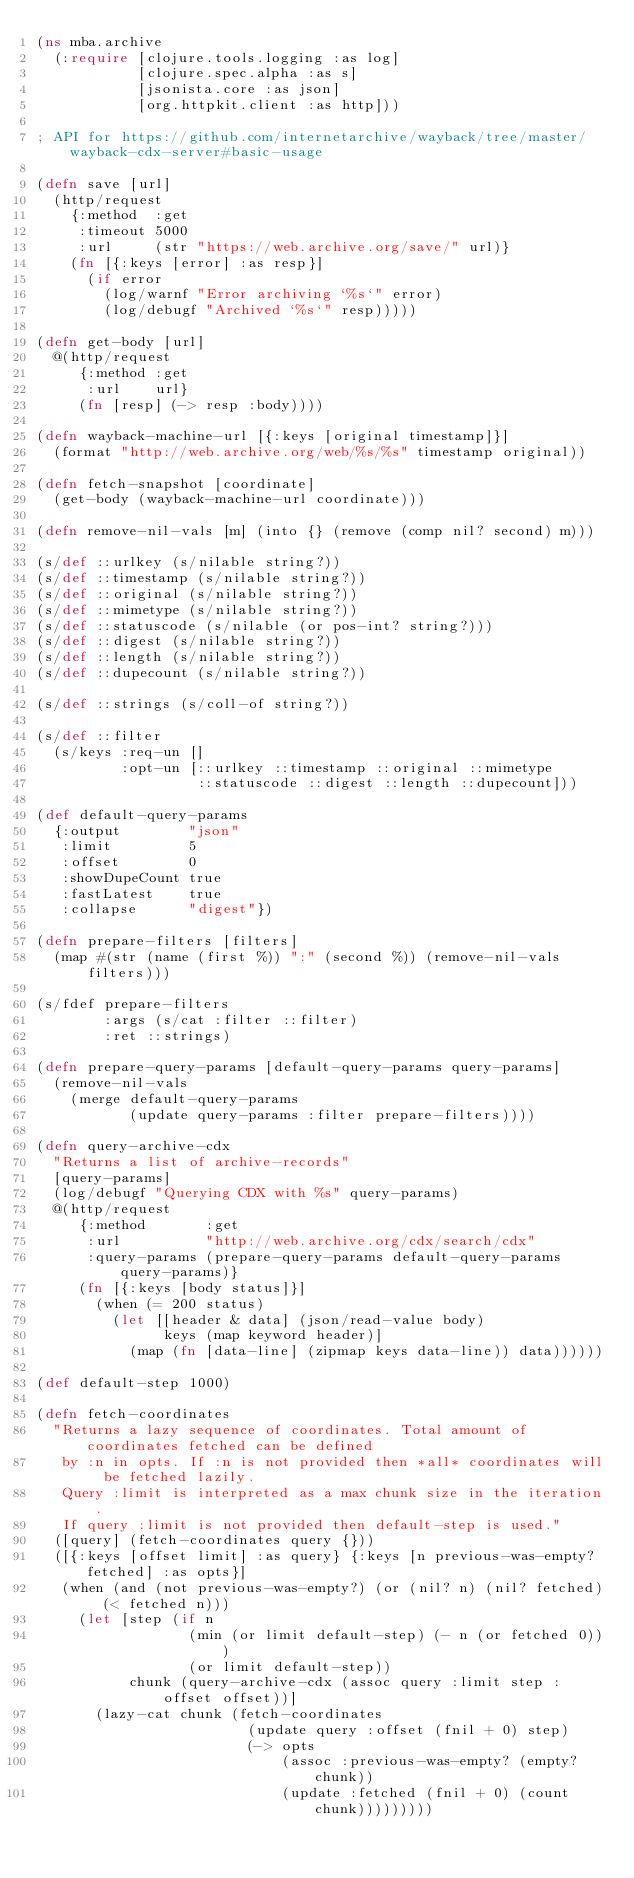Convert code to text. <code><loc_0><loc_0><loc_500><loc_500><_Clojure_>(ns mba.archive
  (:require [clojure.tools.logging :as log]
            [clojure.spec.alpha :as s]
            [jsonista.core :as json]
            [org.httpkit.client :as http]))

; API for https://github.com/internetarchive/wayback/tree/master/wayback-cdx-server#basic-usage

(defn save [url]
  (http/request
    {:method  :get
     :timeout 5000
     :url     (str "https://web.archive.org/save/" url)}
    (fn [{:keys [error] :as resp}]
      (if error
        (log/warnf "Error archiving `%s`" error)
        (log/debugf "Archived `%s`" resp)))))

(defn get-body [url]
  @(http/request
     {:method :get
      :url    url}
     (fn [resp] (-> resp :body))))

(defn wayback-machine-url [{:keys [original timestamp]}]
  (format "http://web.archive.org/web/%s/%s" timestamp original))

(defn fetch-snapshot [coordinate]
  (get-body (wayback-machine-url coordinate)))

(defn remove-nil-vals [m] (into {} (remove (comp nil? second) m)))

(s/def ::urlkey (s/nilable string?))
(s/def ::timestamp (s/nilable string?))
(s/def ::original (s/nilable string?))
(s/def ::mimetype (s/nilable string?))
(s/def ::statuscode (s/nilable (or pos-int? string?)))
(s/def ::digest (s/nilable string?))
(s/def ::length (s/nilable string?))
(s/def ::dupecount (s/nilable string?))

(s/def ::strings (s/coll-of string?))

(s/def ::filter
  (s/keys :req-un []
          :opt-un [::urlkey ::timestamp ::original ::mimetype
                   ::statuscode ::digest ::length ::dupecount]))

(def default-query-params
  {:output        "json"
   :limit         5
   :offset        0
   :showDupeCount true
   :fastLatest    true
   :collapse      "digest"})

(defn prepare-filters [filters]
  (map #(str (name (first %)) ":" (second %)) (remove-nil-vals filters)))

(s/fdef prepare-filters
        :args (s/cat :filter ::filter)
        :ret ::strings)

(defn prepare-query-params [default-query-params query-params]
  (remove-nil-vals
    (merge default-query-params
           (update query-params :filter prepare-filters))))

(defn query-archive-cdx
  "Returns a list of archive-records"
  [query-params]
  (log/debugf "Querying CDX with %s" query-params)
  @(http/request
     {:method       :get
      :url          "http://web.archive.org/cdx/search/cdx"
      :query-params (prepare-query-params default-query-params query-params)}
     (fn [{:keys [body status]}]
       (when (= 200 status)
         (let [[header & data] (json/read-value body)
               keys (map keyword header)]
           (map (fn [data-line] (zipmap keys data-line)) data))))))

(def default-step 1000)

(defn fetch-coordinates
  "Returns a lazy sequence of coordinates. Total amount of coordinates fetched can be defined
   by :n in opts. If :n is not provided then *all* coordinates will be fetched lazily.
   Query :limit is interpreted as a max chunk size in the iteration.
   If query :limit is not provided then default-step is used."
  ([query] (fetch-coordinates query {}))
  ([{:keys [offset limit] :as query} {:keys [n previous-was-empty? fetched] :as opts}]
   (when (and (not previous-was-empty?) (or (nil? n) (nil? fetched) (< fetched n)))
     (let [step (if n
                  (min (or limit default-step) (- n (or fetched 0)))
                  (or limit default-step))
           chunk (query-archive-cdx (assoc query :limit step :offset offset))]
       (lazy-cat chunk (fetch-coordinates
                         (update query :offset (fnil + 0) step)
                         (-> opts
                             (assoc :previous-was-empty? (empty? chunk))
                             (update :fetched (fnil + 0) (count chunk)))))))))
</code> 